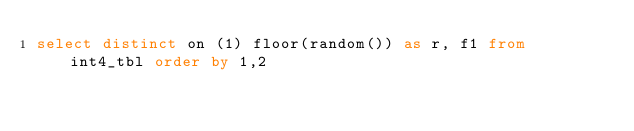Convert code to text. <code><loc_0><loc_0><loc_500><loc_500><_SQL_>select distinct on (1) floor(random()) as r, f1 from int4_tbl order by 1,2
</code> 